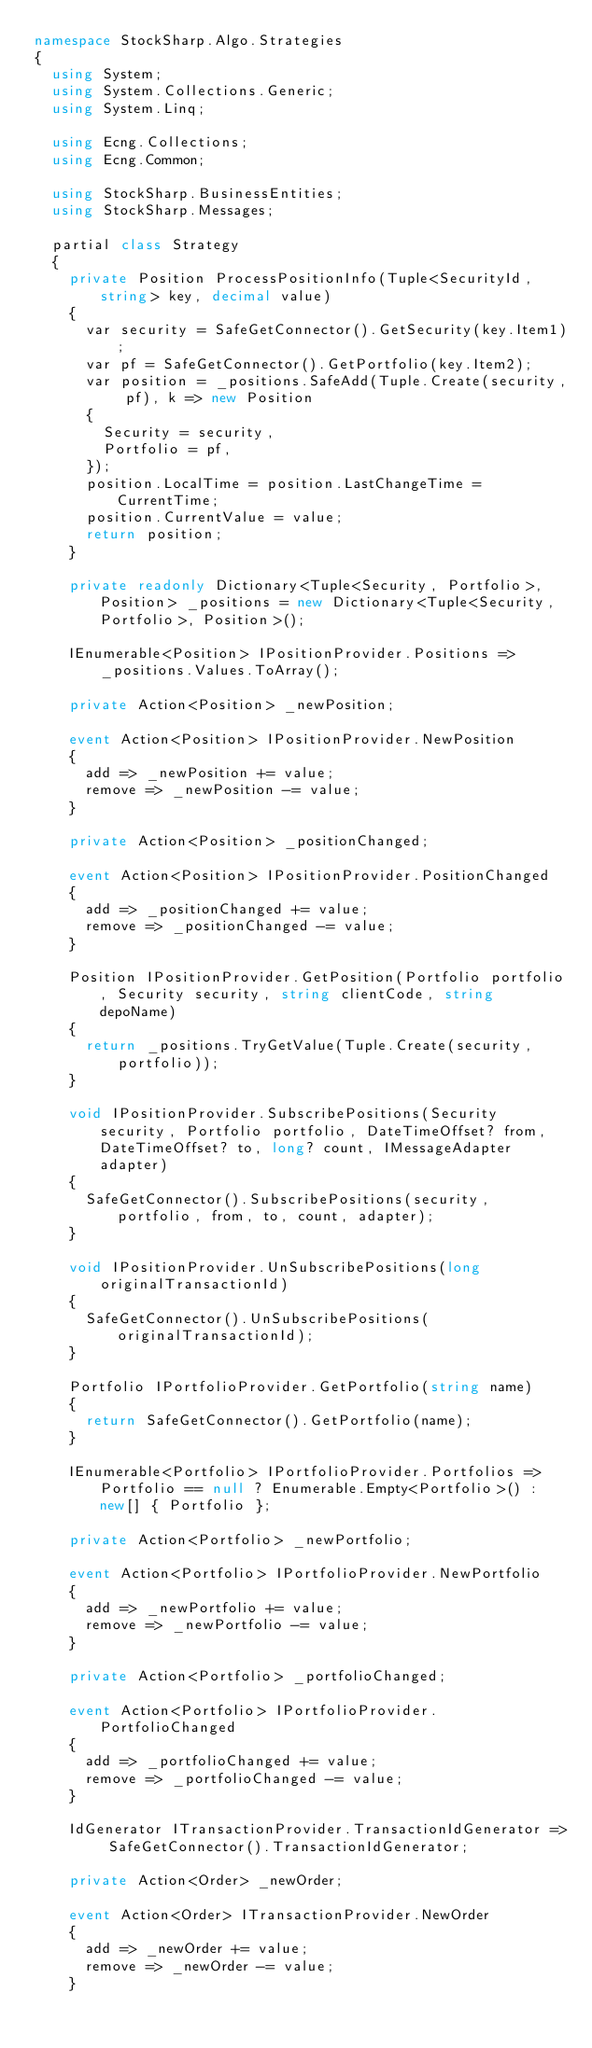Convert code to text. <code><loc_0><loc_0><loc_500><loc_500><_C#_>namespace StockSharp.Algo.Strategies
{
	using System;
	using System.Collections.Generic;
	using System.Linq;

	using Ecng.Collections;
	using Ecng.Common;

	using StockSharp.BusinessEntities;
	using StockSharp.Messages;

	partial class Strategy
	{
		private Position ProcessPositionInfo(Tuple<SecurityId, string> key, decimal value)
		{
			var security = SafeGetConnector().GetSecurity(key.Item1);
			var pf = SafeGetConnector().GetPortfolio(key.Item2);
			var position = _positions.SafeAdd(Tuple.Create(security, pf), k => new Position
			{
				Security = security,
				Portfolio = pf,
			});
			position.LocalTime = position.LastChangeTime = CurrentTime;
			position.CurrentValue = value;
			return position;
		}

		private readonly Dictionary<Tuple<Security, Portfolio>, Position> _positions = new Dictionary<Tuple<Security, Portfolio>, Position>();

		IEnumerable<Position> IPositionProvider.Positions => _positions.Values.ToArray();

		private Action<Position> _newPosition;

		event Action<Position> IPositionProvider.NewPosition
		{
			add => _newPosition += value;
			remove => _newPosition -= value;
		}

		private Action<Position> _positionChanged;

		event Action<Position> IPositionProvider.PositionChanged
		{
			add => _positionChanged += value;
			remove => _positionChanged -= value;
		}

		Position IPositionProvider.GetPosition(Portfolio portfolio, Security security, string clientCode, string depoName)
		{
			return _positions.TryGetValue(Tuple.Create(security, portfolio));
		}

		void IPositionProvider.SubscribePositions(Security security, Portfolio portfolio, DateTimeOffset? from, DateTimeOffset? to, long? count, IMessageAdapter adapter)
		{
			SafeGetConnector().SubscribePositions(security, portfolio, from, to, count, adapter);
		}

		void IPositionProvider.UnSubscribePositions(long originalTransactionId)
		{
			SafeGetConnector().UnSubscribePositions(originalTransactionId);
		}

		Portfolio IPortfolioProvider.GetPortfolio(string name)
		{
			return SafeGetConnector().GetPortfolio(name);
		}

		IEnumerable<Portfolio> IPortfolioProvider.Portfolios => Portfolio == null ? Enumerable.Empty<Portfolio>() : new[] { Portfolio };

		private Action<Portfolio> _newPortfolio;

		event Action<Portfolio> IPortfolioProvider.NewPortfolio
		{
			add => _newPortfolio += value;
			remove => _newPortfolio -= value;
		}

		private Action<Portfolio> _portfolioChanged;

		event Action<Portfolio> IPortfolioProvider.PortfolioChanged
		{
			add => _portfolioChanged += value;
			remove => _portfolioChanged -= value;
		}

		IdGenerator ITransactionProvider.TransactionIdGenerator => SafeGetConnector().TransactionIdGenerator;

		private Action<Order> _newOrder;

		event Action<Order> ITransactionProvider.NewOrder
		{
			add => _newOrder += value;
			remove => _newOrder -= value;
		}
</code> 